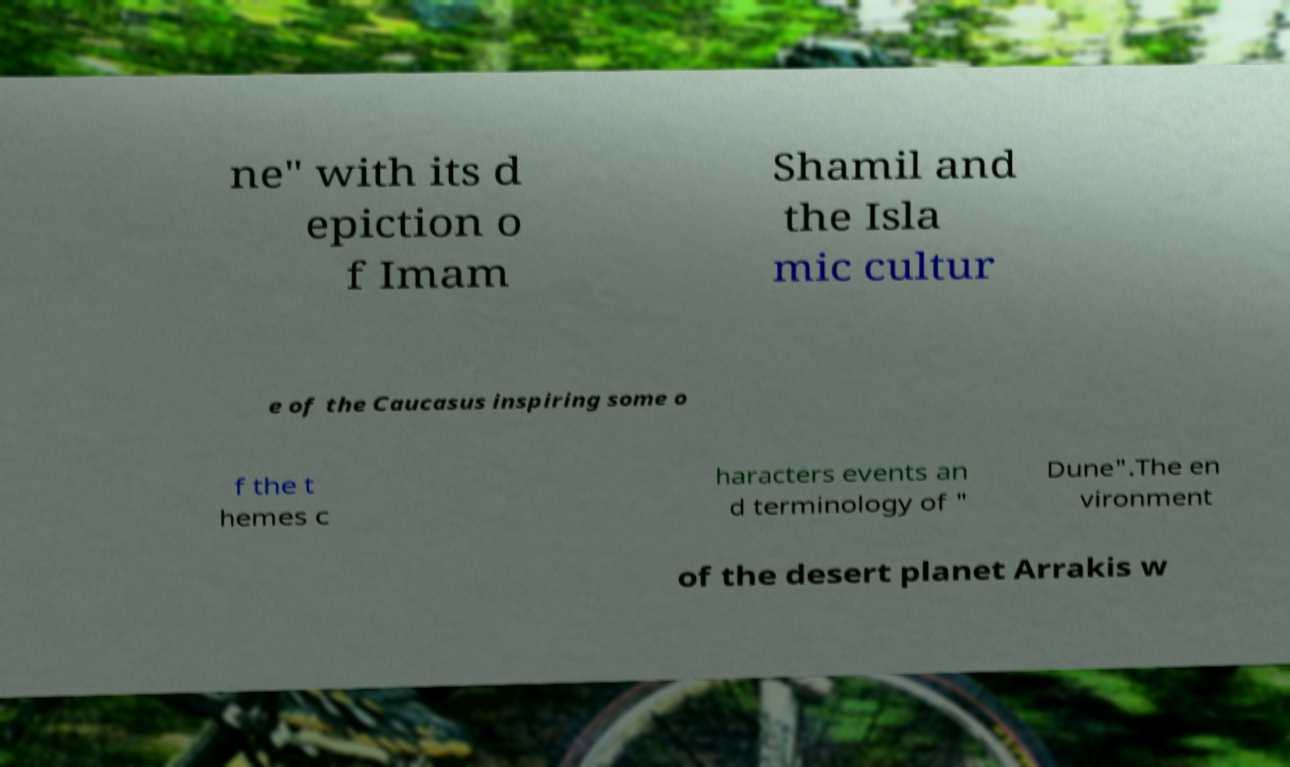For documentation purposes, I need the text within this image transcribed. Could you provide that? ne" with its d epiction o f Imam Shamil and the Isla mic cultur e of the Caucasus inspiring some o f the t hemes c haracters events an d terminology of " Dune".The en vironment of the desert planet Arrakis w 